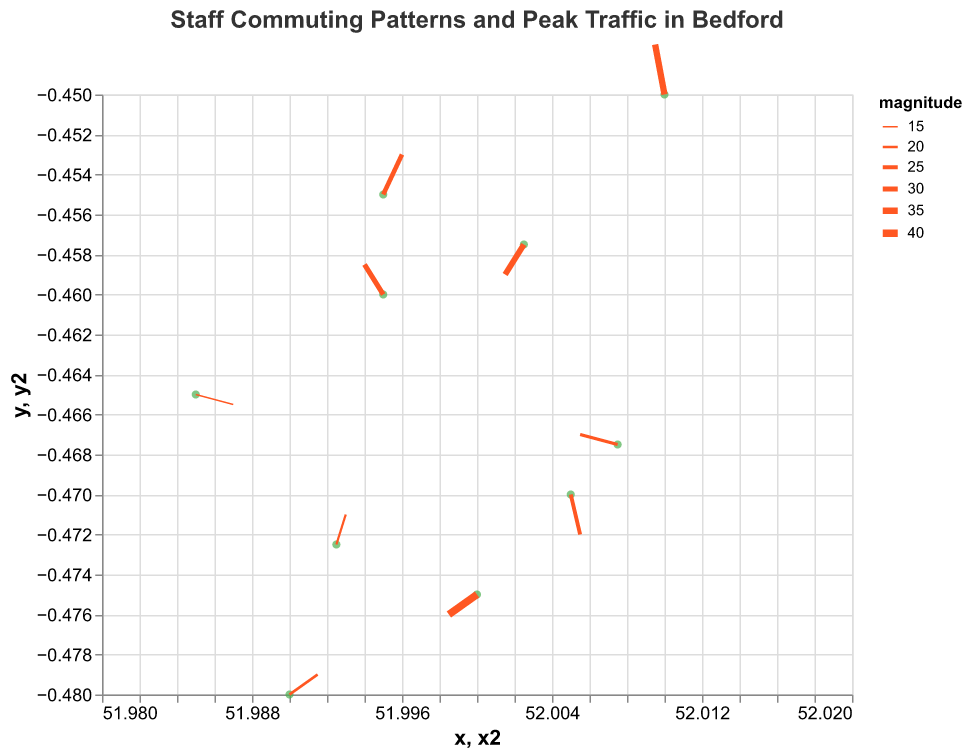What's the title of the plot? The title of the plot is displayed at the top and reads "Staff Commuting Patterns and Peak Traffic in Bedford".
Answer: Staff Commuting Patterns and Peak Traffic in Bedford How many data points are represented in the plot? By looking at the number of points on the plot, you can count that there are 10 data points. Each point corresponds to a staff position with commuting direction and magnitude.
Answer: 10 What are the x and y ranges shown in the plot? The x-axis ranges from approximately [51.98 to 52.02], and the y-axis ranges from [-0.48 to -0.45]. These are the limits specified for the axis scales.
Answer: x: [51.98, 52.02], y: [-0.48, -0.45] Which data point has the largest commuting magnitude, and what is its value? By examining the varying stroke widths of the red arrows, the data point with the largest stroke width represents the largest magnitude. The widest arrow is at (52.0000, -0.4750) with a magnitude of 40.
Answer: (52.0000, -0.4750) with 40 What is the average magnitude of the commuting vectors? To find the average magnitude, sum all the magnitudes and divide by the number of data points. The total magnitude is (30 + 25 + 20 + 35 + 15 + 40 + 28 + 22 + 18 + 33) = 266. Dividing by 10 data points, the average magnitude is 266 / 10.
Answer: 26.6 Which data point shows the greatest increase in x coordinates, and how much is the increase? The greatest increase in x-coordinates can be identified by checking the u-component (change in x) visually and numerically. The data point (51.9850, -0.4650) shows the highest positive u value of 0.4. The increase is 0.4 * 0.005 = 0.002.
Answer: (51.9850, -0.4650) with an increase of 0.002 Are there more vectors pointing in the northeast direction or the southwest direction? Northeast direction vectors have both positive u and positive v components, while southwest direction vectors have both negative u and negative v components. Count the vectors in each direction by examining the direction of the red arrows. There are 2 vectors pointing northeast and 3 vectors pointing southwest.
Answer: More vectors point in southwest direction What is the direction and magnitude of the vector originating from (52.0100, -0.4500)? The vector originating from (52.0100, -0.4500) can be identified by its coordinates and u, v components. It has a u of -0.1 and a v of 0.5. To find its direction, it points left (negative x) and up (positive y), and its magnitude is specified as 35.
Answer: Direction: left and up, Magnitude: 35 Which data point has the smallest u value, and what is the resulting change in x-coordinate? The smallest u value in the dataset is -0.4 found at (52.0075, -0.4675). The change in x-coordinate is calculated as u * 0.005, resulting in -0.4 * 0.005 = -0.002.
Answer: (52.0075, -0.4675) with a change of -0.002 